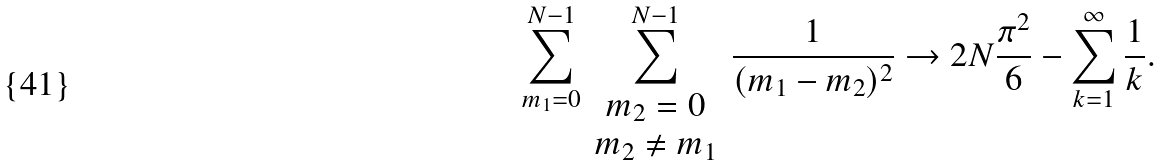<formula> <loc_0><loc_0><loc_500><loc_500>\sum _ { m _ { 1 } = 0 } ^ { N - 1 } \sum _ { \begin{array} { c } m _ { 2 } = 0 \\ m _ { 2 } \neq m _ { 1 } \end{array} } ^ { N - 1 } \frac { 1 } { ( m _ { 1 } - m _ { 2 } ) ^ { 2 } } \rightarrow 2 N \frac { \pi ^ { 2 } } { 6 } - \sum _ { k = 1 } ^ { \infty } \frac { 1 } { k } .</formula> 